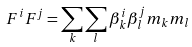<formula> <loc_0><loc_0><loc_500><loc_500>F ^ { i } F ^ { j } = \sum _ { k } \sum _ { l } \beta _ { k } ^ { i } \beta _ { l } ^ { j } m _ { k } m _ { l }</formula> 